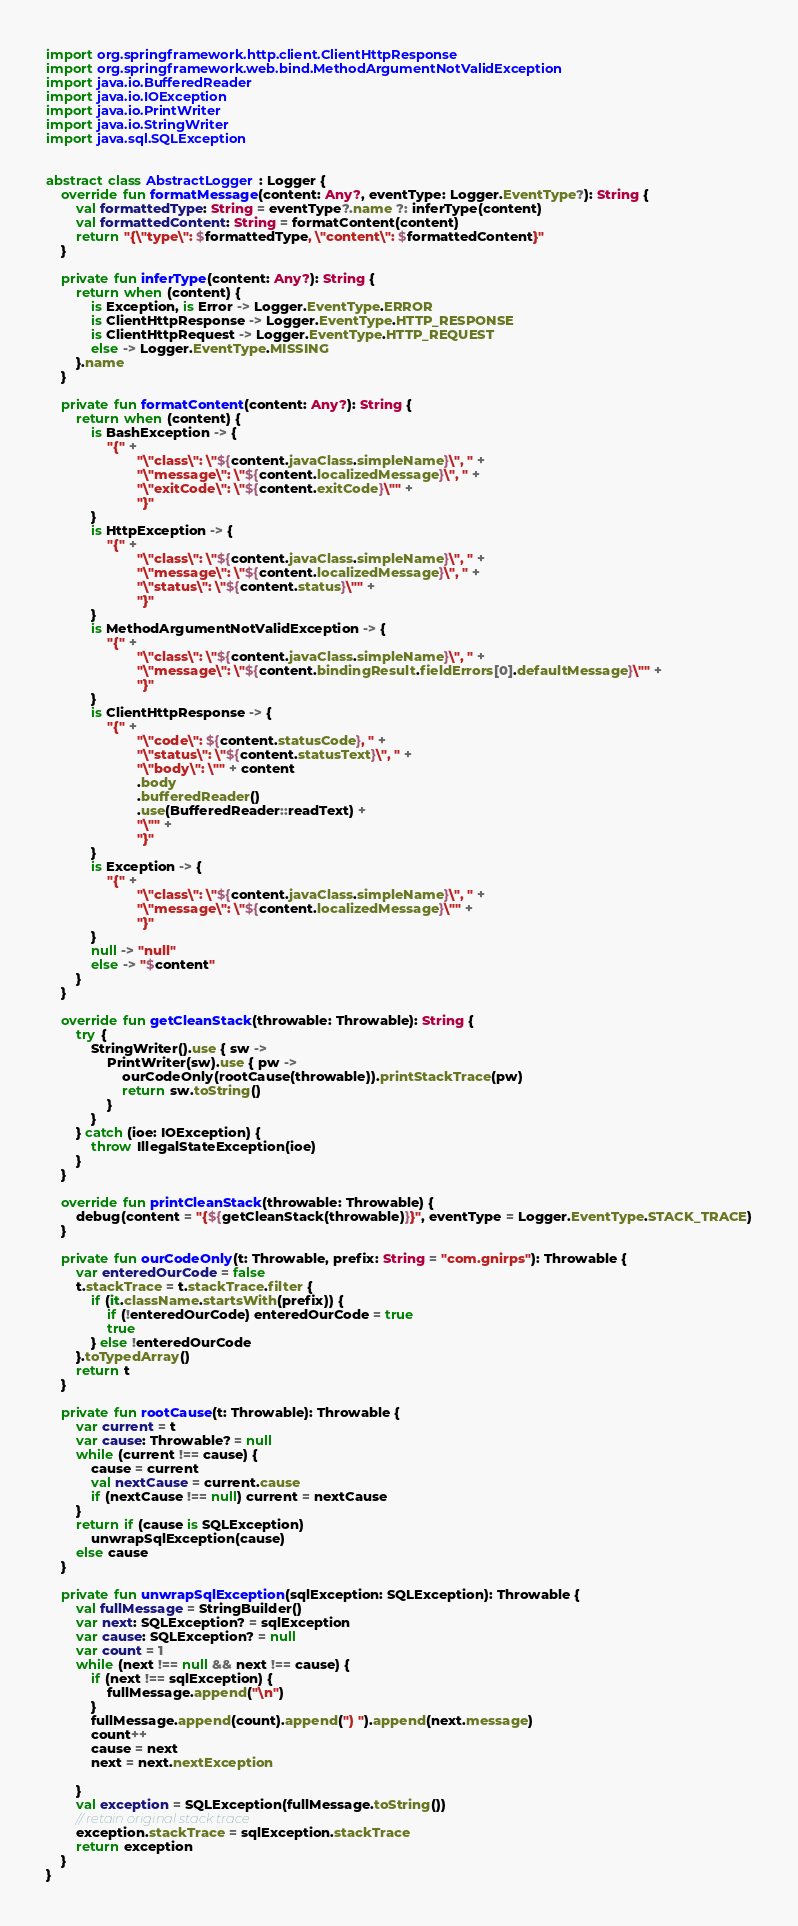Convert code to text. <code><loc_0><loc_0><loc_500><loc_500><_Kotlin_>import org.springframework.http.client.ClientHttpResponse
import org.springframework.web.bind.MethodArgumentNotValidException
import java.io.BufferedReader
import java.io.IOException
import java.io.PrintWriter
import java.io.StringWriter
import java.sql.SQLException


abstract class AbstractLogger : Logger {
    override fun formatMessage(content: Any?, eventType: Logger.EventType?): String {
        val formattedType: String = eventType?.name ?: inferType(content)
        val formattedContent: String = formatContent(content)
        return "{\"type\": $formattedType, \"content\": $formattedContent}"
    }

    private fun inferType(content: Any?): String {
        return when (content) {
            is Exception, is Error -> Logger.EventType.ERROR
            is ClientHttpResponse -> Logger.EventType.HTTP_RESPONSE
            is ClientHttpRequest -> Logger.EventType.HTTP_REQUEST
            else -> Logger.EventType.MISSING
        }.name
    }

    private fun formatContent(content: Any?): String {
        return when (content) {
            is BashException -> {
                "{" +
                        "\"class\": \"${content.javaClass.simpleName}\", " +
                        "\"message\": \"${content.localizedMessage}\", " +
                        "\"exitCode\": \"${content.exitCode}\"" +
                        "}"
            }
            is HttpException -> {
                "{" +
                        "\"class\": \"${content.javaClass.simpleName}\", " +
                        "\"message\": \"${content.localizedMessage}\", " +
                        "\"status\": \"${content.status}\"" +
                        "}"
            }
            is MethodArgumentNotValidException -> {
                "{" +
                        "\"class\": \"${content.javaClass.simpleName}\", " +
                        "\"message\": \"${content.bindingResult.fieldErrors[0].defaultMessage}\"" +
                        "}"
            }
            is ClientHttpResponse -> {
                "{" +
                        "\"code\": ${content.statusCode}, " +
                        "\"status\": \"${content.statusText}\", " +
                        "\"body\": \"" + content
                        .body
                        .bufferedReader()
                        .use(BufferedReader::readText) +
                        "\"" +
                        "}"
            }
            is Exception -> {
                "{" +
                        "\"class\": \"${content.javaClass.simpleName}\", " +
                        "\"message\": \"${content.localizedMessage}\"" +
                        "}"
            }
            null -> "null"
            else -> "$content"
        }
    }

    override fun getCleanStack(throwable: Throwable): String {
        try {
            StringWriter().use { sw ->
                PrintWriter(sw).use { pw ->
                    ourCodeOnly(rootCause(throwable)).printStackTrace(pw)
                    return sw.toString()
                }
            }
        } catch (ioe: IOException) {
            throw IllegalStateException(ioe)
        }
    }

    override fun printCleanStack(throwable: Throwable) {
        debug(content = "{${getCleanStack(throwable)}}", eventType = Logger.EventType.STACK_TRACE)
    }

    private fun ourCodeOnly(t: Throwable, prefix: String = "com.gnirps"): Throwable {
        var enteredOurCode = false
        t.stackTrace = t.stackTrace.filter {
            if (it.className.startsWith(prefix)) {
                if (!enteredOurCode) enteredOurCode = true
                true
            } else !enteredOurCode
        }.toTypedArray()
        return t
    }

    private fun rootCause(t: Throwable): Throwable {
        var current = t
        var cause: Throwable? = null
        while (current !== cause) {
            cause = current
            val nextCause = current.cause
            if (nextCause !== null) current = nextCause
        }
        return if (cause is SQLException)
            unwrapSqlException(cause)
        else cause
    }

    private fun unwrapSqlException(sqlException: SQLException): Throwable {
        val fullMessage = StringBuilder()
        var next: SQLException? = sqlException
        var cause: SQLException? = null
        var count = 1
        while (next !== null && next !== cause) {
            if (next !== sqlException) {
                fullMessage.append("\n")
            }
            fullMessage.append(count).append(") ").append(next.message)
            count++
            cause = next
            next = next.nextException

        }
        val exception = SQLException(fullMessage.toString())
        // retain original stack trace
        exception.stackTrace = sqlException.stackTrace
        return exception
    }
}</code> 